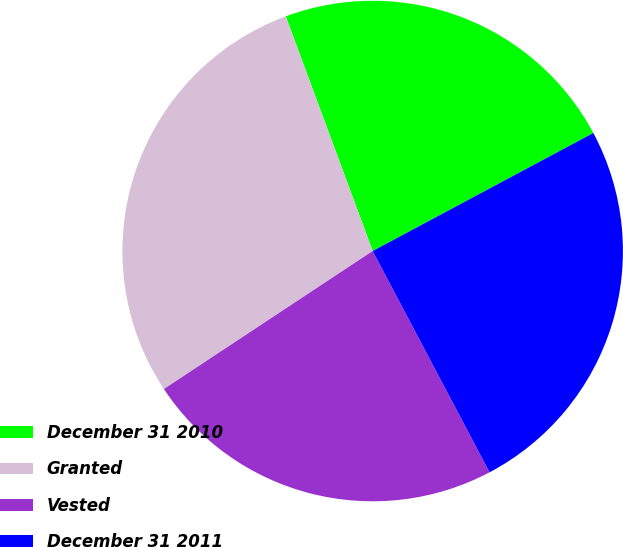Convert chart to OTSL. <chart><loc_0><loc_0><loc_500><loc_500><pie_chart><fcel>December 31 2010<fcel>Granted<fcel>Vested<fcel>December 31 2011<nl><fcel>22.83%<fcel>28.65%<fcel>23.44%<fcel>25.08%<nl></chart> 